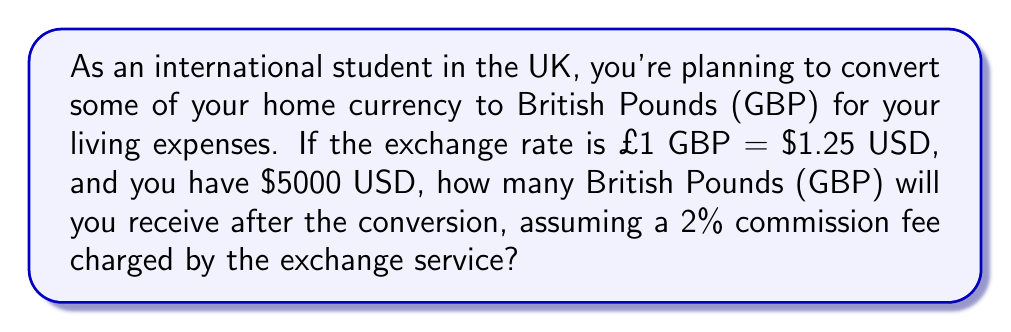Can you answer this question? Let's approach this problem step by step:

1. First, let's calculate the conversion without the commission fee:
   $\frac{\$5000 \text{ USD}}{$1.25 \text{ USD/GBP}} = £4000 \text{ GBP}$

2. Now, we need to account for the 2% commission fee:
   $2\% = 0.02$
   
   The amount we'll receive after the fee is:
   $£4000 \times (1 - 0.02) = £4000 \times 0.98 = £3920 \text{ GBP}$

3. To verify, let's check if the math works in reverse:
   $£3920 \text{ GBP} \times 1.25 \text{ USD/GBP} = \$4900 \text{ USD}$
   $\$4900 \text{ USD} + (\$5000 \times 0.02) = \$4900 + \$100 = \$5000 \text{ USD}$

This confirms our calculation is correct.
Answer: $£3920 \text{ GBP}$ 